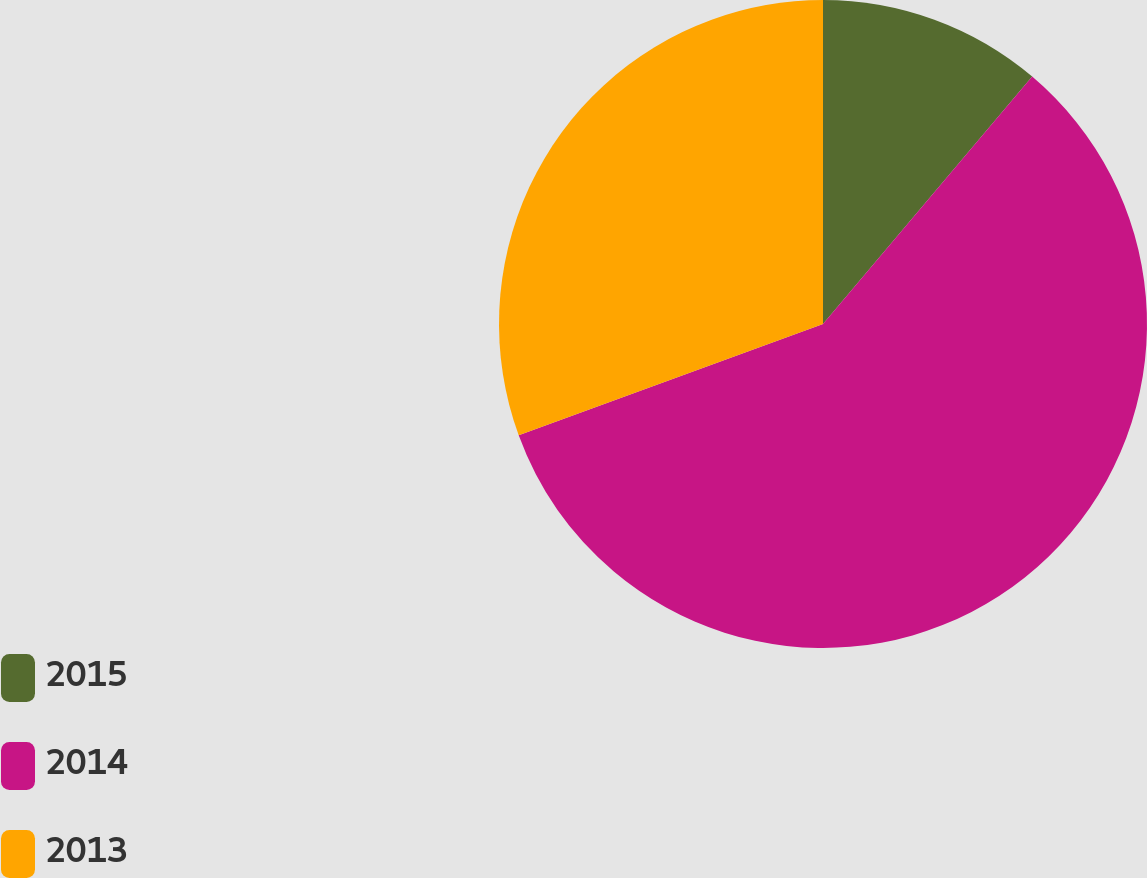Convert chart. <chart><loc_0><loc_0><loc_500><loc_500><pie_chart><fcel>2015<fcel>2014<fcel>2013<nl><fcel>11.17%<fcel>58.25%<fcel>30.58%<nl></chart> 